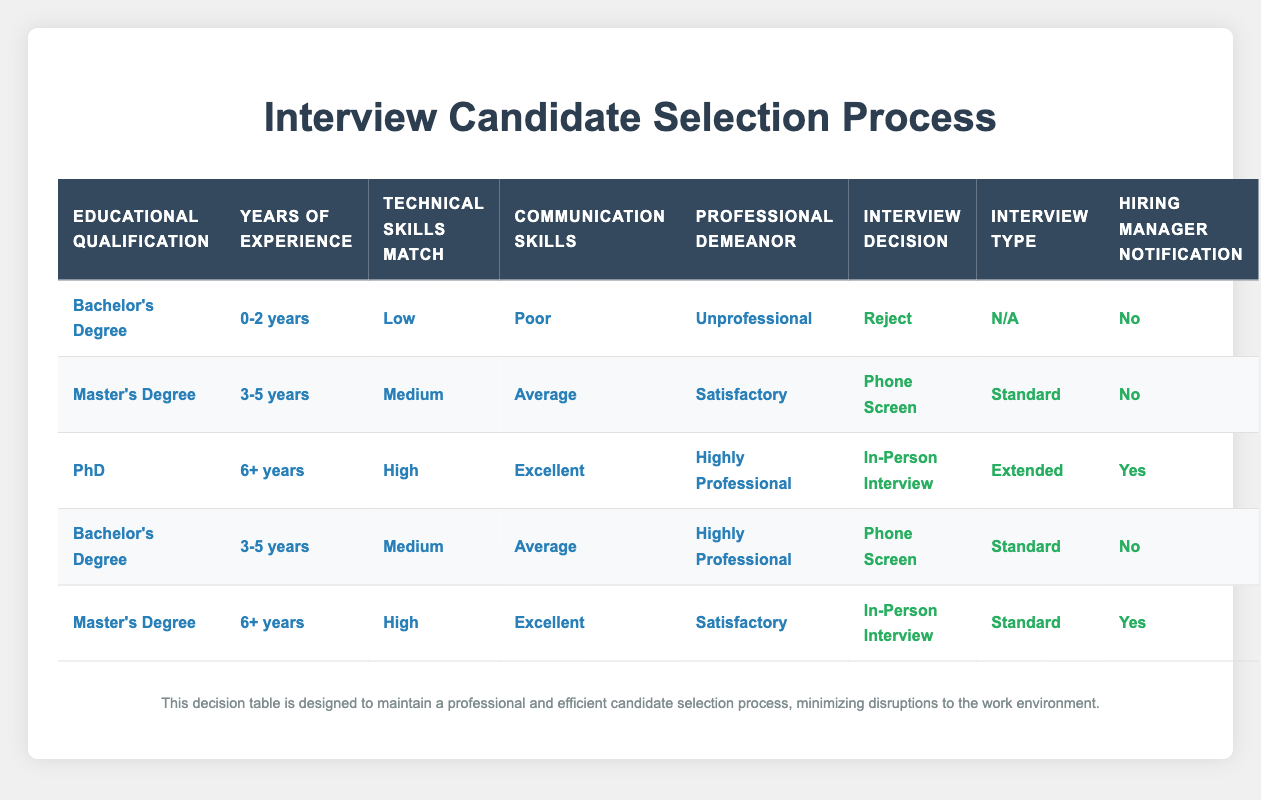What is the interview decision for a candidate with a Bachelor's Degree, 0-2 years of experience, low technical skills, poor communication, and unprofessional demeanor? The table specifies the interview decision for this combination of conditions as "Reject," which is explicitly stated in the corresponding row.
Answer: Reject How many candidates will receive a phone screen based on their qualifications? There are two rows in the table with the action of "Phone Screen." The first one is for a candidate with a Master's Degree and 3-5 years of experience, and the second is for a candidate with a Bachelor's Degree and 3-5 years of experience having satisfactory communication and highly professional demeanor. Thus, there are two candidates overall.
Answer: 2 Is a candidate with a PhD, 6+ years of experience, high technical skills, excellent communication skills, and a highly professional demeanor guaranteed an in-person interview? According to the table, this set of conditions directly leads to the action "In-Person Interview," confirming that such a candidate is indeed guaranteed an interview.
Answer: Yes What is the hiring manager notification status for candidates with a Master's Degree and 6+ years of experience? The table shows that the corresponding action for this candidate is "Yes" for hiring manager notification, indicating that the manager will be notified in this scenario.
Answer: Yes If a candidate with a Bachelor's Degree and 3-5 years of experience has excellent communication skills and a satisfactory professional demeanor, what will be the interview decision? Looking at the table, although they have a Bachelor's Degree and 3-5 years of experience, their communication skills are classified as "Excellent," with professional demeanor listed as "Satisfactory." However, there is no direct match for this combination in the table, and thus a definitive answer cannot be provided.
Answer: Not Found What is the average years of experience for candidates that will receive an in-person interview? From the table, we note that two candidates receive an in-person interview: one with a PhD and 6+ years of experience and one with a Master's Degree and 6+ years of experience. Both have 6+ years, so calculating the average gives us (6+6)/2 = 6.
Answer: 6 How many candidates with a Bachelor's Degree are rejected? The table indicates that there is one candidate with a Bachelor's Degree who is rejected based on their low technical skills, poor communication, and unprofessional demeanor. Hence, only one candidate meets these conditions.
Answer: 1 Is the interview decision for a candidate with a Master's Degree, 3-5 years of experience, medium technical skills, average communication skills, and satisfactory demeanor a phone screen? The conditions for this candidate show that it indeed results in a "Phone Screen," as explicitly provided in the appropriate row of the table.
Answer: Yes 